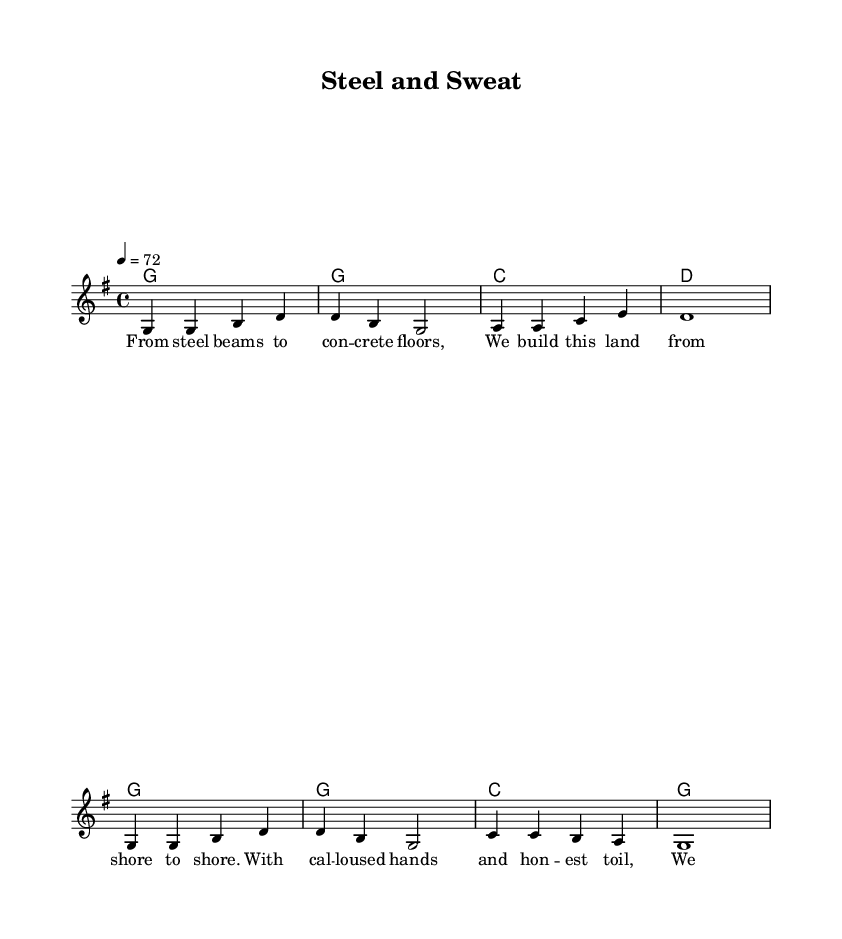What is the key signature of this music? The key signature is G major, which has one sharp (F#). This can be determined by looking at the key signature indicated at the beginning of the staff.
Answer: G major What is the time signature of this music? The time signature is 4/4, as seen at the beginning of the staff where the numbers are displayed. This indicates four beats per measure, with each beat represented by a quarter note.
Answer: 4/4 What is the tempo marking for this piece? The tempo marking is 72 beats per minute, indicated by the notation "4 = 72" at the beginning of the score, which means there are 72 quarter note beats in one minute.
Answer: 72 How many measures are there in the melody? There are eight measures in the melody, as counted from the beginning to the end of the melody line, each separated by a vertical line.
Answer: 8 What is the main theme of the lyrics? The main theme of the lyrics celebrates American industry and manufacturing, particularly the hard work and dedication that goes into building the nation. This theme can be identified through key phrases in the lyrics such as "build this land" and "honest toil."
Answer: American industry What chords are used in the piece? The chords used in the piece are G, C, and D, as shown in the chord symbols beneath the melody line. These chords support the melody and provide harmonic structure.
Answer: G, C, D What type of piece is "Steel and Sweat"? "Steel and Sweat" is a classic country ballad, characterized by its storytelling lyrics and simple harmonic structure, which is typical of the country music genre. The lyrical content relates directly to themes prevalent in country music.
Answer: Classic country ballad 